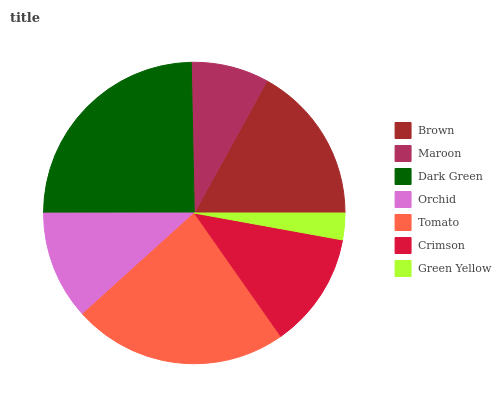Is Green Yellow the minimum?
Answer yes or no. Yes. Is Dark Green the maximum?
Answer yes or no. Yes. Is Maroon the minimum?
Answer yes or no. No. Is Maroon the maximum?
Answer yes or no. No. Is Brown greater than Maroon?
Answer yes or no. Yes. Is Maroon less than Brown?
Answer yes or no. Yes. Is Maroon greater than Brown?
Answer yes or no. No. Is Brown less than Maroon?
Answer yes or no. No. Is Crimson the high median?
Answer yes or no. Yes. Is Crimson the low median?
Answer yes or no. Yes. Is Green Yellow the high median?
Answer yes or no. No. Is Maroon the low median?
Answer yes or no. No. 